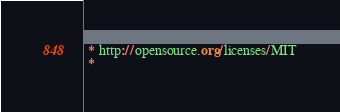<code> <loc_0><loc_0><loc_500><loc_500><_CSS_> * http://opensource.org/licenses/MIT
 *</code> 